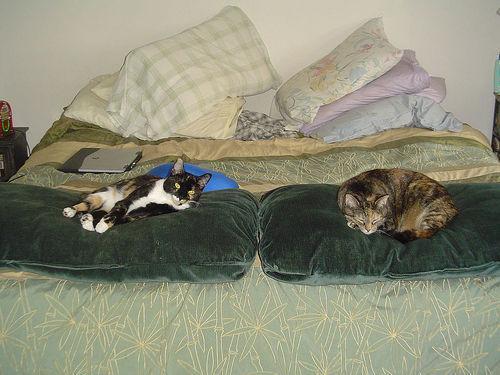How many people are in the picture?
Give a very brief answer. 0. 